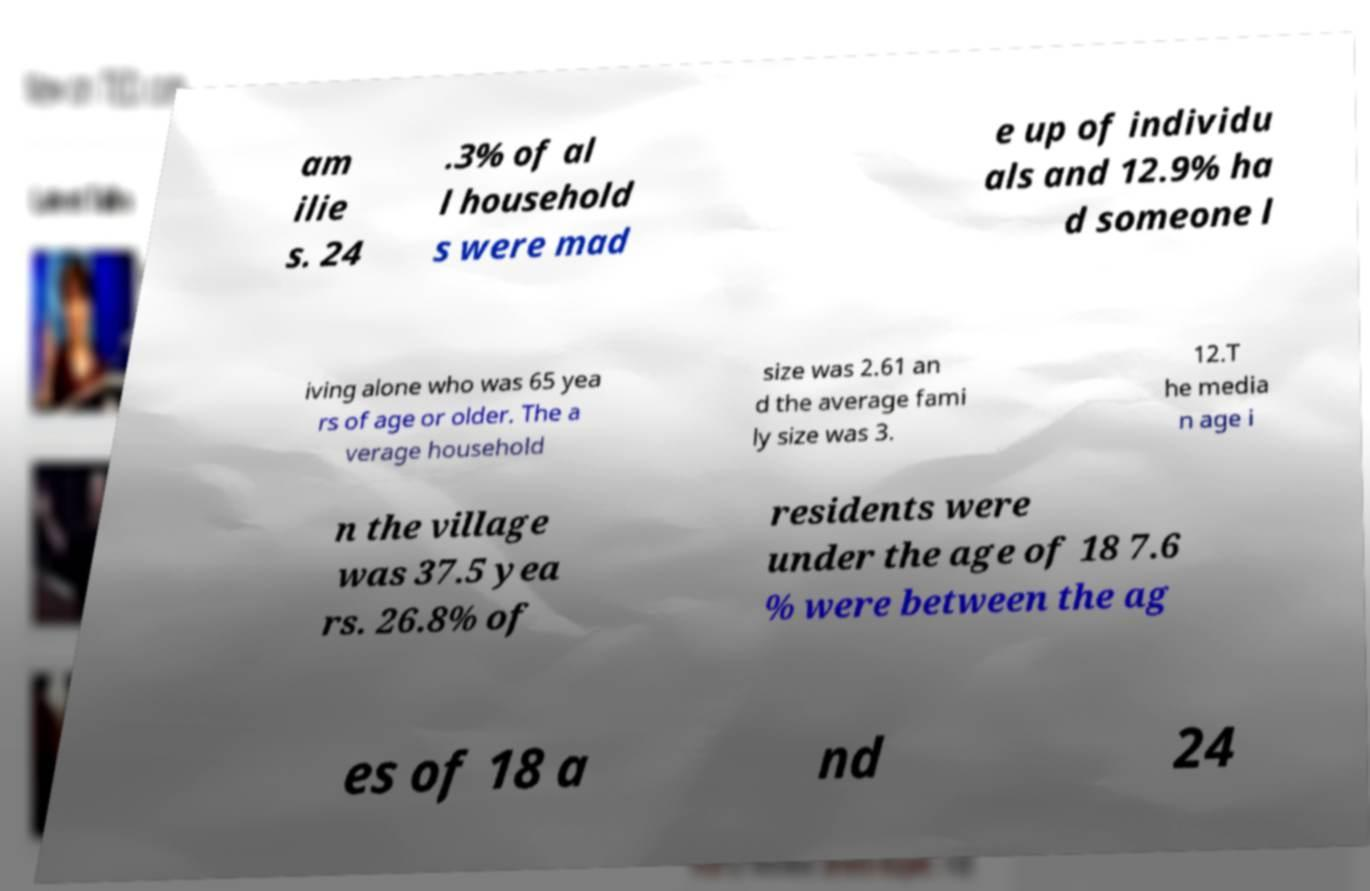There's text embedded in this image that I need extracted. Can you transcribe it verbatim? am ilie s. 24 .3% of al l household s were mad e up of individu als and 12.9% ha d someone l iving alone who was 65 yea rs of age or older. The a verage household size was 2.61 an d the average fami ly size was 3. 12.T he media n age i n the village was 37.5 yea rs. 26.8% of residents were under the age of 18 7.6 % were between the ag es of 18 a nd 24 